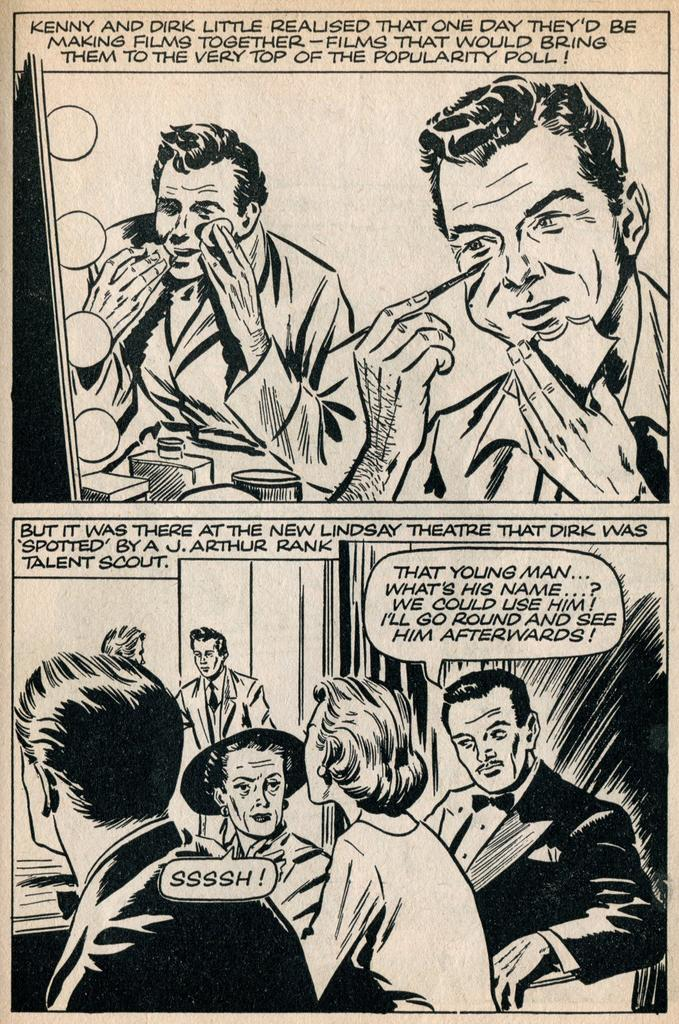<image>
Offer a succinct explanation of the picture presented. Two frames from a black and white comic book concerning actors hoping to be discovered by Rank. 